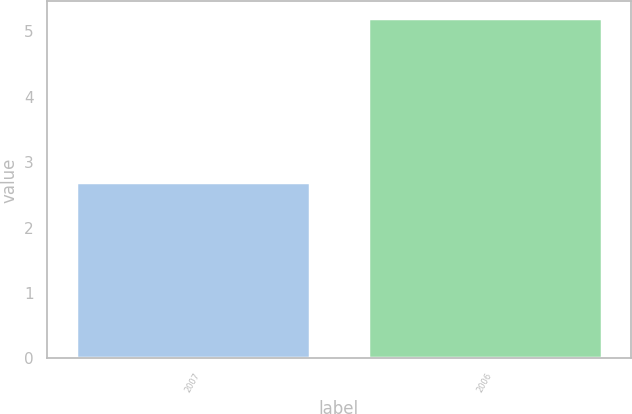Convert chart to OTSL. <chart><loc_0><loc_0><loc_500><loc_500><bar_chart><fcel>2007<fcel>2006<nl><fcel>2.7<fcel>5.2<nl></chart> 